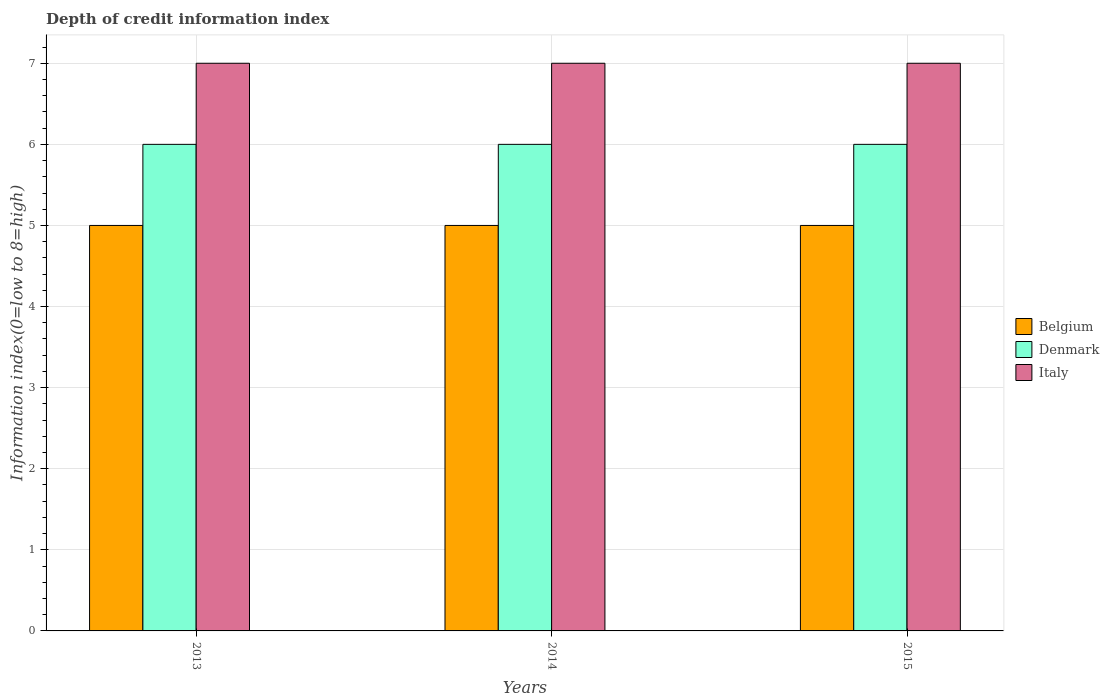How many groups of bars are there?
Offer a very short reply. 3. Are the number of bars on each tick of the X-axis equal?
Offer a terse response. Yes. How many bars are there on the 1st tick from the right?
Your answer should be compact. 3. What is the label of the 2nd group of bars from the left?
Provide a succinct answer. 2014. What is the information index in Italy in 2013?
Provide a succinct answer. 7. Across all years, what is the maximum information index in Belgium?
Your answer should be very brief. 5. Across all years, what is the minimum information index in Belgium?
Your response must be concise. 5. In which year was the information index in Belgium maximum?
Offer a very short reply. 2013. In which year was the information index in Italy minimum?
Offer a very short reply. 2013. What is the total information index in Denmark in the graph?
Your response must be concise. 18. What is the difference between the information index in Denmark in 2015 and the information index in Italy in 2013?
Offer a very short reply. -1. In the year 2014, what is the difference between the information index in Italy and information index in Denmark?
Your answer should be very brief. 1. Is the information index in Denmark in 2013 less than that in 2014?
Offer a very short reply. No. What is the difference between the highest and the second highest information index in Belgium?
Your response must be concise. 0. Is the sum of the information index in Italy in 2013 and 2014 greater than the maximum information index in Belgium across all years?
Ensure brevity in your answer.  Yes. What does the 1st bar from the right in 2015 represents?
Offer a terse response. Italy. Is it the case that in every year, the sum of the information index in Italy and information index in Belgium is greater than the information index in Denmark?
Keep it short and to the point. Yes. How many bars are there?
Make the answer very short. 9. How many years are there in the graph?
Give a very brief answer. 3. Are the values on the major ticks of Y-axis written in scientific E-notation?
Make the answer very short. No. Does the graph contain grids?
Ensure brevity in your answer.  Yes. Where does the legend appear in the graph?
Provide a short and direct response. Center right. How many legend labels are there?
Your response must be concise. 3. What is the title of the graph?
Offer a very short reply. Depth of credit information index. Does "Nigeria" appear as one of the legend labels in the graph?
Provide a succinct answer. No. What is the label or title of the Y-axis?
Give a very brief answer. Information index(0=low to 8=high). What is the Information index(0=low to 8=high) in Denmark in 2013?
Offer a terse response. 6. What is the Information index(0=low to 8=high) of Italy in 2013?
Offer a very short reply. 7. What is the Information index(0=low to 8=high) in Belgium in 2014?
Offer a very short reply. 5. What is the Information index(0=low to 8=high) in Italy in 2014?
Keep it short and to the point. 7. What is the Information index(0=low to 8=high) in Belgium in 2015?
Make the answer very short. 5. What is the Information index(0=low to 8=high) of Italy in 2015?
Your answer should be very brief. 7. Across all years, what is the maximum Information index(0=low to 8=high) of Belgium?
Provide a succinct answer. 5. Across all years, what is the maximum Information index(0=low to 8=high) in Italy?
Offer a terse response. 7. Across all years, what is the minimum Information index(0=low to 8=high) in Denmark?
Your answer should be very brief. 6. Across all years, what is the minimum Information index(0=low to 8=high) of Italy?
Your answer should be very brief. 7. What is the total Information index(0=low to 8=high) of Denmark in the graph?
Your response must be concise. 18. What is the difference between the Information index(0=low to 8=high) in Belgium in 2013 and that in 2014?
Make the answer very short. 0. What is the difference between the Information index(0=low to 8=high) in Belgium in 2013 and that in 2015?
Provide a short and direct response. 0. What is the difference between the Information index(0=low to 8=high) of Denmark in 2013 and that in 2015?
Provide a succinct answer. 0. What is the difference between the Information index(0=low to 8=high) of Italy in 2013 and that in 2015?
Offer a very short reply. 0. What is the difference between the Information index(0=low to 8=high) of Belgium in 2014 and that in 2015?
Your answer should be very brief. 0. What is the difference between the Information index(0=low to 8=high) in Belgium in 2013 and the Information index(0=low to 8=high) in Denmark in 2014?
Offer a terse response. -1. What is the difference between the Information index(0=low to 8=high) of Belgium in 2013 and the Information index(0=low to 8=high) of Denmark in 2015?
Provide a short and direct response. -1. What is the difference between the Information index(0=low to 8=high) in Belgium in 2013 and the Information index(0=low to 8=high) in Italy in 2015?
Your answer should be compact. -2. What is the difference between the Information index(0=low to 8=high) in Belgium in 2014 and the Information index(0=low to 8=high) in Denmark in 2015?
Keep it short and to the point. -1. What is the difference between the Information index(0=low to 8=high) in Denmark in 2014 and the Information index(0=low to 8=high) in Italy in 2015?
Your response must be concise. -1. What is the average Information index(0=low to 8=high) of Denmark per year?
Offer a very short reply. 6. What is the average Information index(0=low to 8=high) of Italy per year?
Your response must be concise. 7. In the year 2014, what is the difference between the Information index(0=low to 8=high) in Belgium and Information index(0=low to 8=high) in Denmark?
Make the answer very short. -1. In the year 2014, what is the difference between the Information index(0=low to 8=high) of Belgium and Information index(0=low to 8=high) of Italy?
Provide a succinct answer. -2. In the year 2015, what is the difference between the Information index(0=low to 8=high) of Belgium and Information index(0=low to 8=high) of Italy?
Offer a terse response. -2. What is the ratio of the Information index(0=low to 8=high) of Denmark in 2013 to that in 2014?
Your response must be concise. 1. What is the ratio of the Information index(0=low to 8=high) of Belgium in 2013 to that in 2015?
Provide a short and direct response. 1. What is the ratio of the Information index(0=low to 8=high) of Italy in 2013 to that in 2015?
Offer a very short reply. 1. What is the difference between the highest and the second highest Information index(0=low to 8=high) of Belgium?
Give a very brief answer. 0. What is the difference between the highest and the second highest Information index(0=low to 8=high) in Italy?
Ensure brevity in your answer.  0. What is the difference between the highest and the lowest Information index(0=low to 8=high) of Denmark?
Provide a succinct answer. 0. 